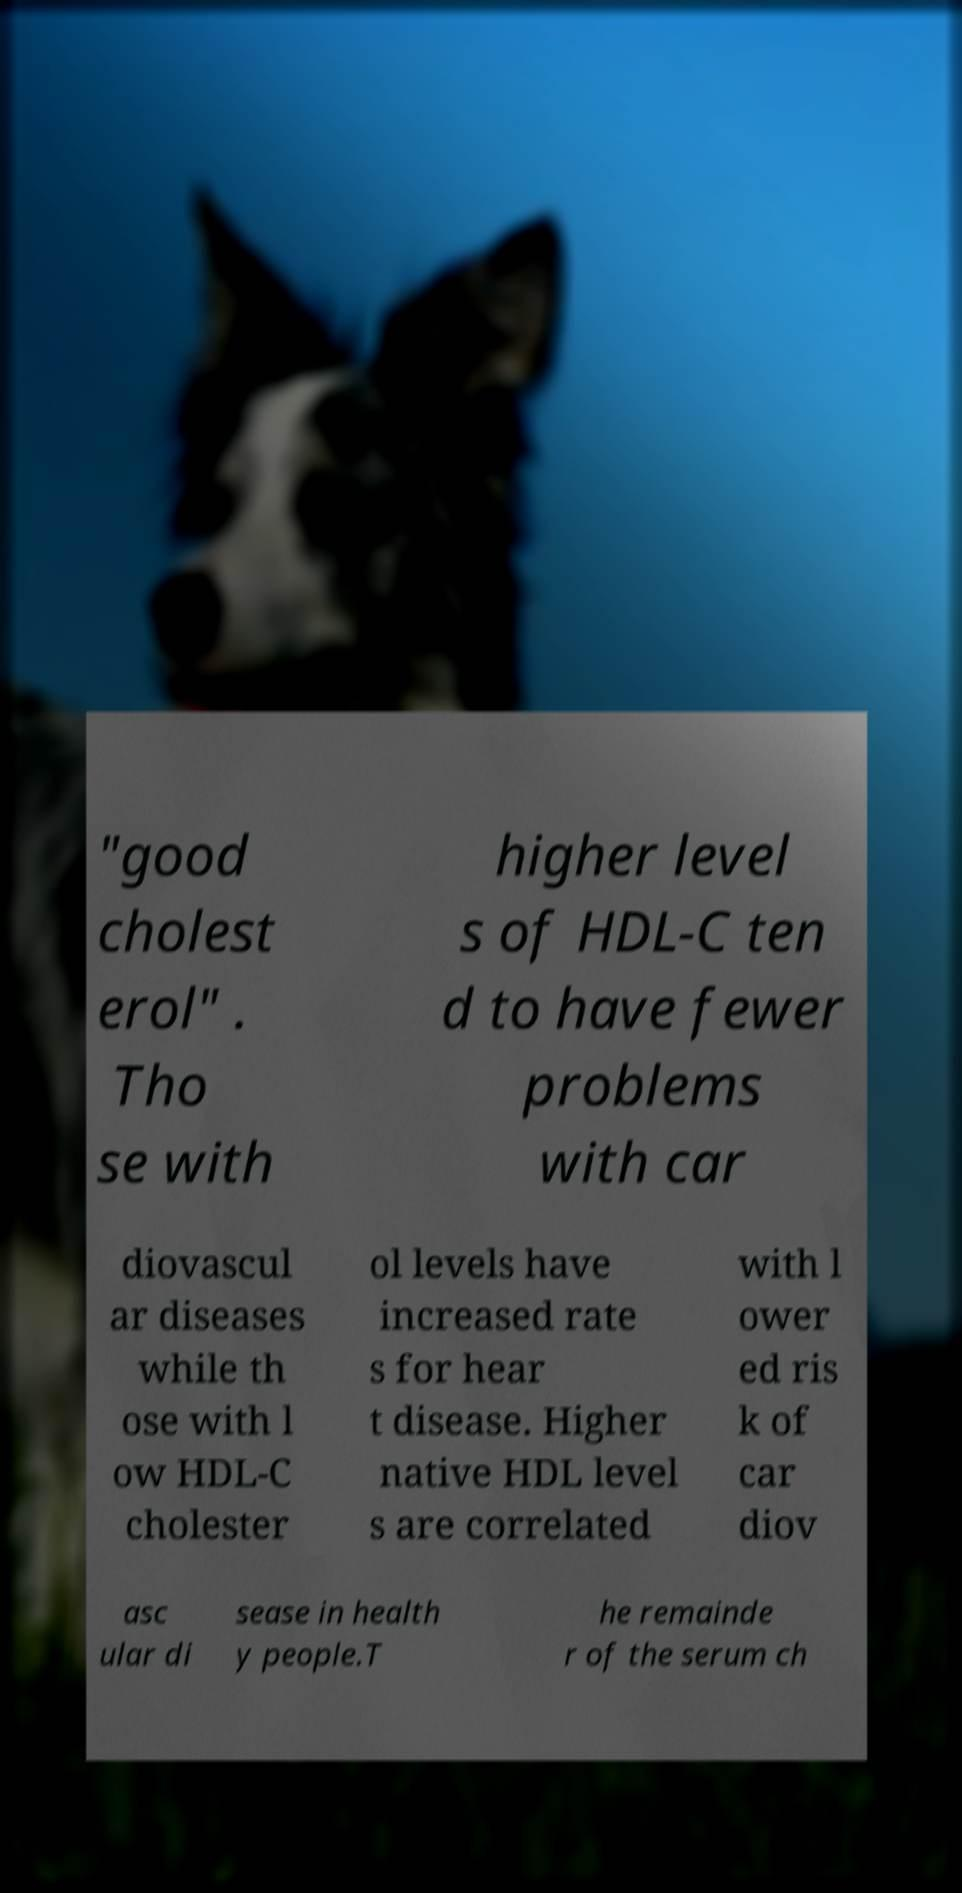Please read and relay the text visible in this image. What does it say? "good cholest erol" . Tho se with higher level s of HDL-C ten d to have fewer problems with car diovascul ar diseases while th ose with l ow HDL-C cholester ol levels have increased rate s for hear t disease. Higher native HDL level s are correlated with l ower ed ris k of car diov asc ular di sease in health y people.T he remainde r of the serum ch 